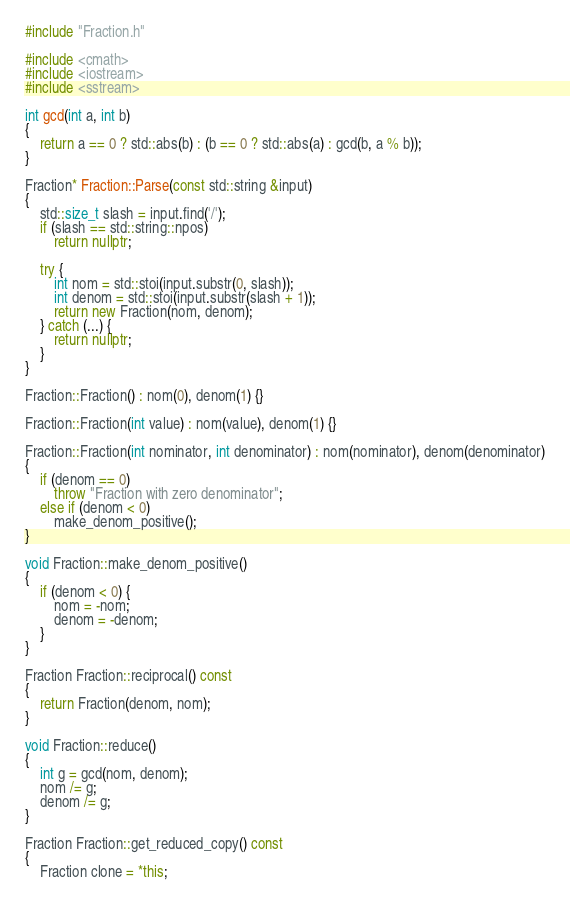Convert code to text. <code><loc_0><loc_0><loc_500><loc_500><_C++_>#include "Fraction.h"

#include <cmath>
#include <iostream>
#include <sstream>

int gcd(int a, int b)
{
    return a == 0 ? std::abs(b) : (b == 0 ? std::abs(a) : gcd(b, a % b));
}

Fraction* Fraction::Parse(const std::string &input)
{
    std::size_t slash = input.find('/');
    if (slash == std::string::npos)
        return nullptr;
    
    try {
        int nom = std::stoi(input.substr(0, slash));
        int denom = std::stoi(input.substr(slash + 1));
        return new Fraction(nom, denom);
    } catch (...) {
        return nullptr;
    }
}

Fraction::Fraction() : nom(0), denom(1) {}

Fraction::Fraction(int value) : nom(value), denom(1) {}

Fraction::Fraction(int nominator, int denominator) : nom(nominator), denom(denominator)
{
    if (denom == 0)
        throw "Fraction with zero denominator";
    else if (denom < 0)
        make_denom_positive();
}

void Fraction::make_denom_positive()
{
    if (denom < 0) {
        nom = -nom;
        denom = -denom;
    }
}

Fraction Fraction::reciprocal() const
{
    return Fraction(denom, nom);
}

void Fraction::reduce()
{
    int g = gcd(nom, denom);
    nom /= g;
    denom /= g;
}

Fraction Fraction::get_reduced_copy() const
{
    Fraction clone = *this;</code> 